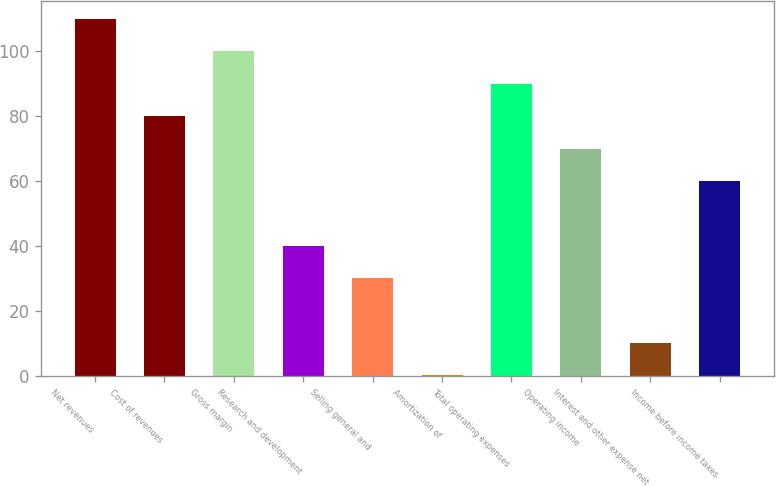Convert chart to OTSL. <chart><loc_0><loc_0><loc_500><loc_500><bar_chart><fcel>Net revenues<fcel>Cost of revenues<fcel>Gross margin<fcel>Research and development<fcel>Selling general and<fcel>Amortization of<fcel>Total operating expenses<fcel>Operating income<fcel>Interest and other expense net<fcel>Income before income taxes<nl><fcel>109.96<fcel>80.08<fcel>100<fcel>40.24<fcel>30.28<fcel>0.4<fcel>90.04<fcel>70.12<fcel>10.36<fcel>60.16<nl></chart> 